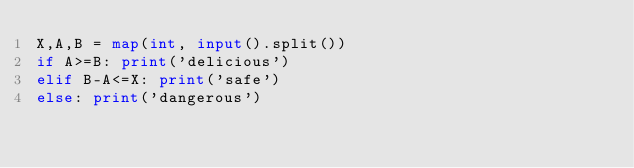Convert code to text. <code><loc_0><loc_0><loc_500><loc_500><_Python_>X,A,B = map(int, input().split())
if A>=B: print('delicious')
elif B-A<=X: print('safe')
else: print('dangerous')</code> 